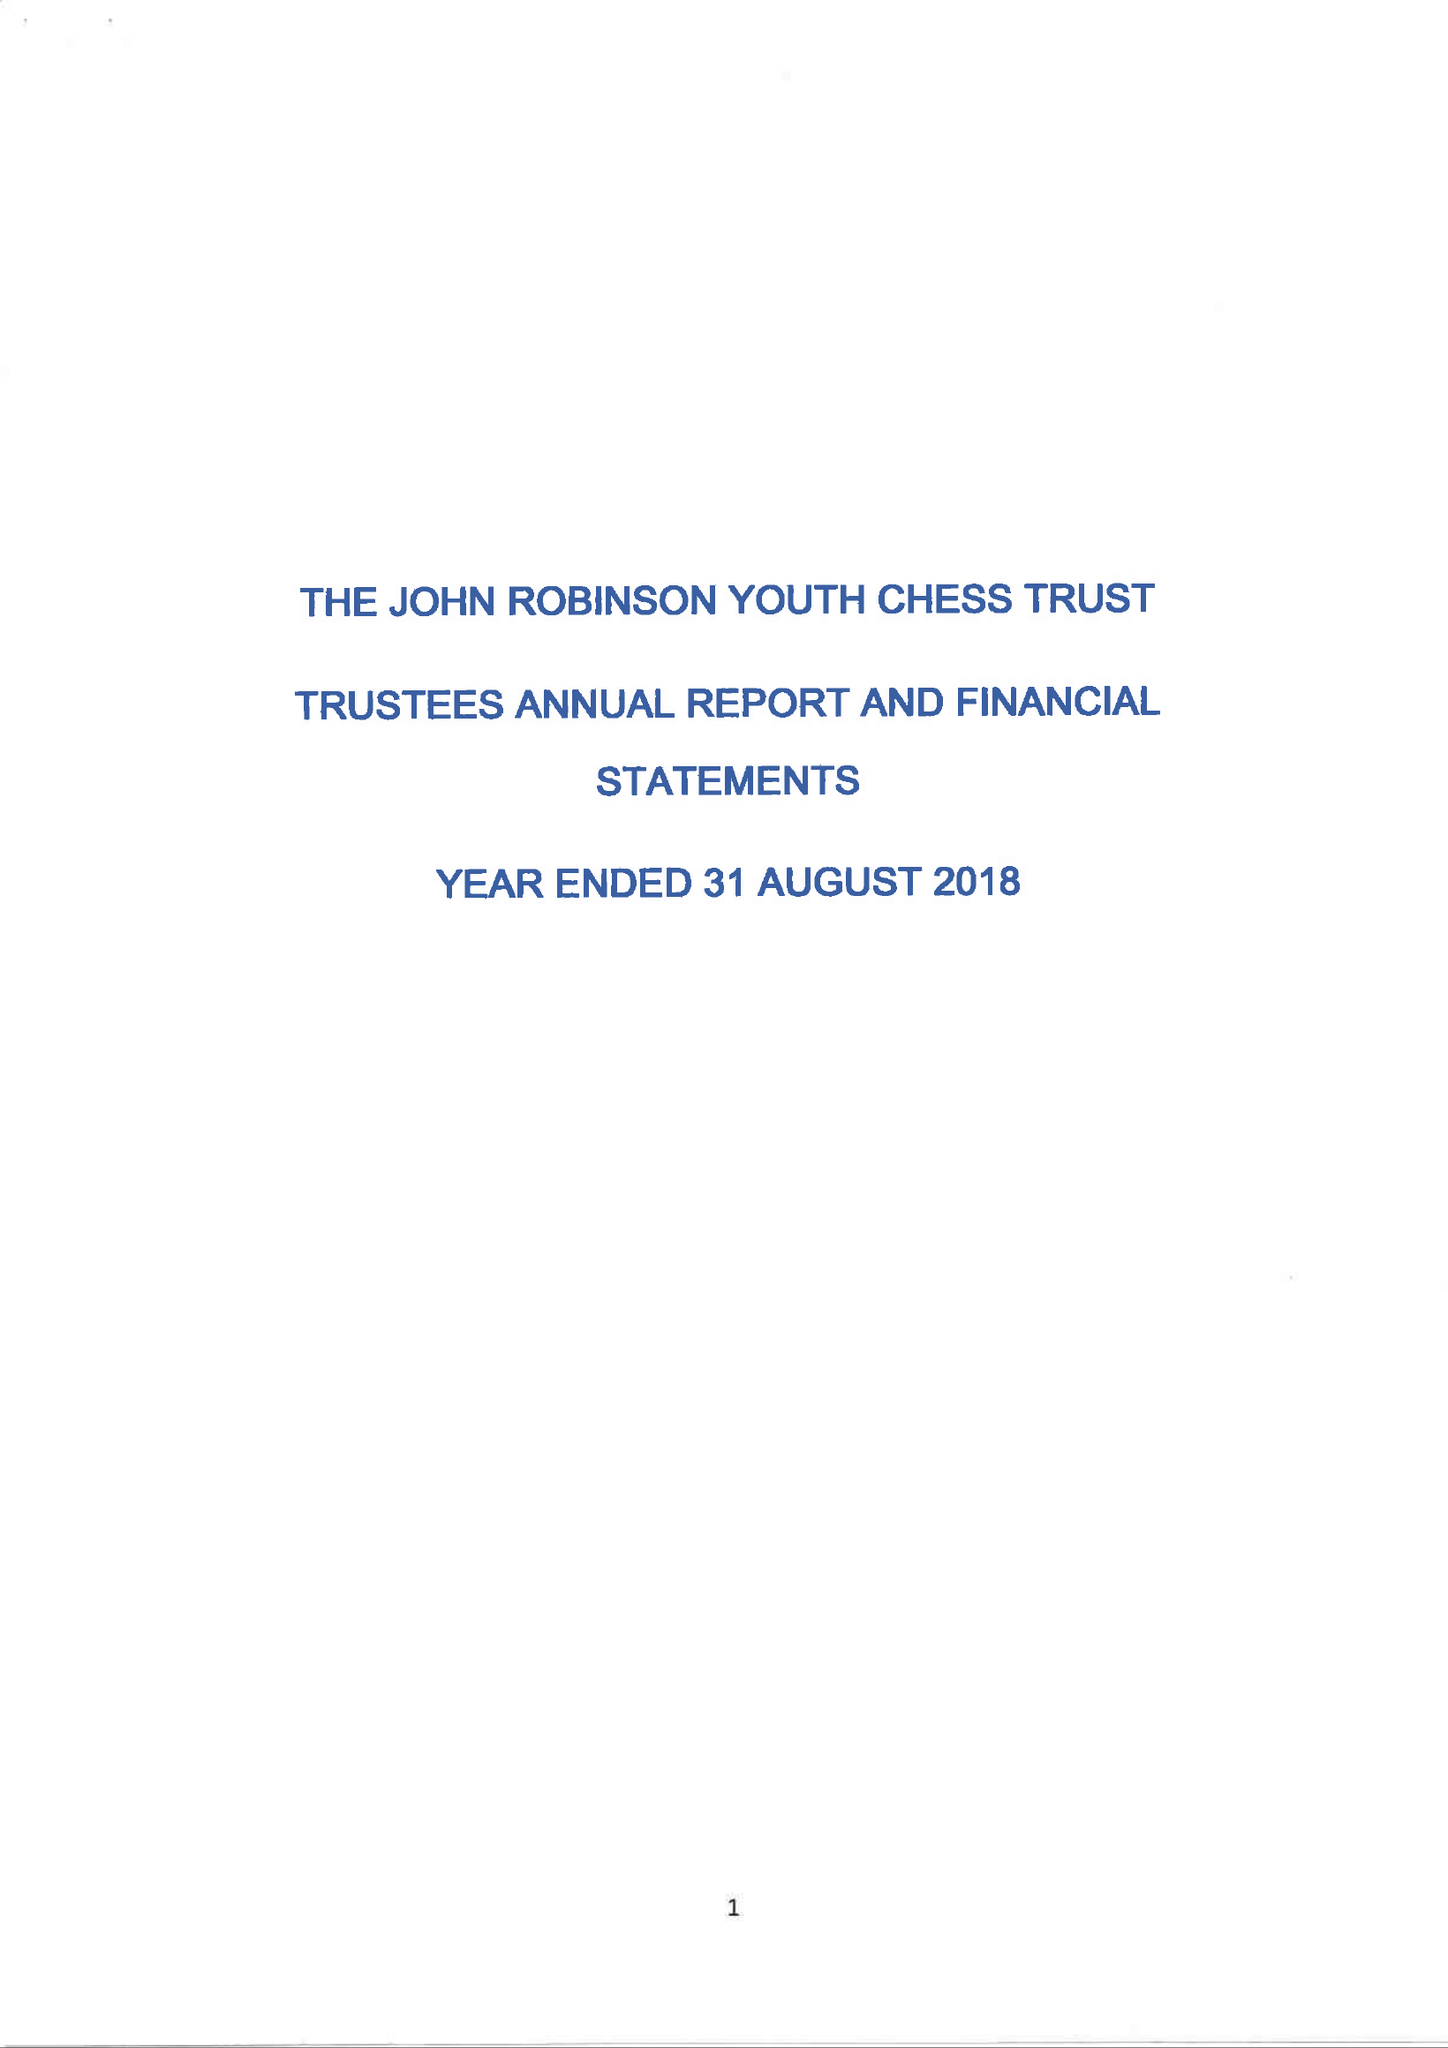What is the value for the income_annually_in_british_pounds?
Answer the question using a single word or phrase. 27200.00 